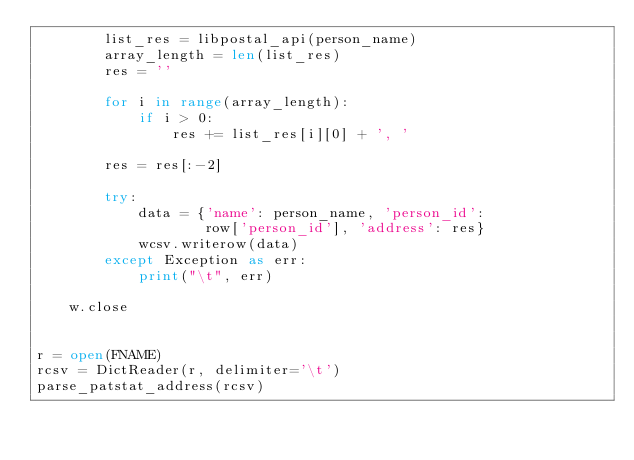<code> <loc_0><loc_0><loc_500><loc_500><_Python_>        list_res = libpostal_api(person_name)
        array_length = len(list_res)
        res = ''

        for i in range(array_length):
            if i > 0:
                res += list_res[i][0] + ', '

        res = res[:-2]

        try:
            data = {'name': person_name, 'person_id':
                    row['person_id'], 'address': res}
            wcsv.writerow(data)
        except Exception as err:
            print("\t", err)

    w.close


r = open(FNAME)
rcsv = DictReader(r, delimiter='\t')
parse_patstat_address(rcsv)
</code> 